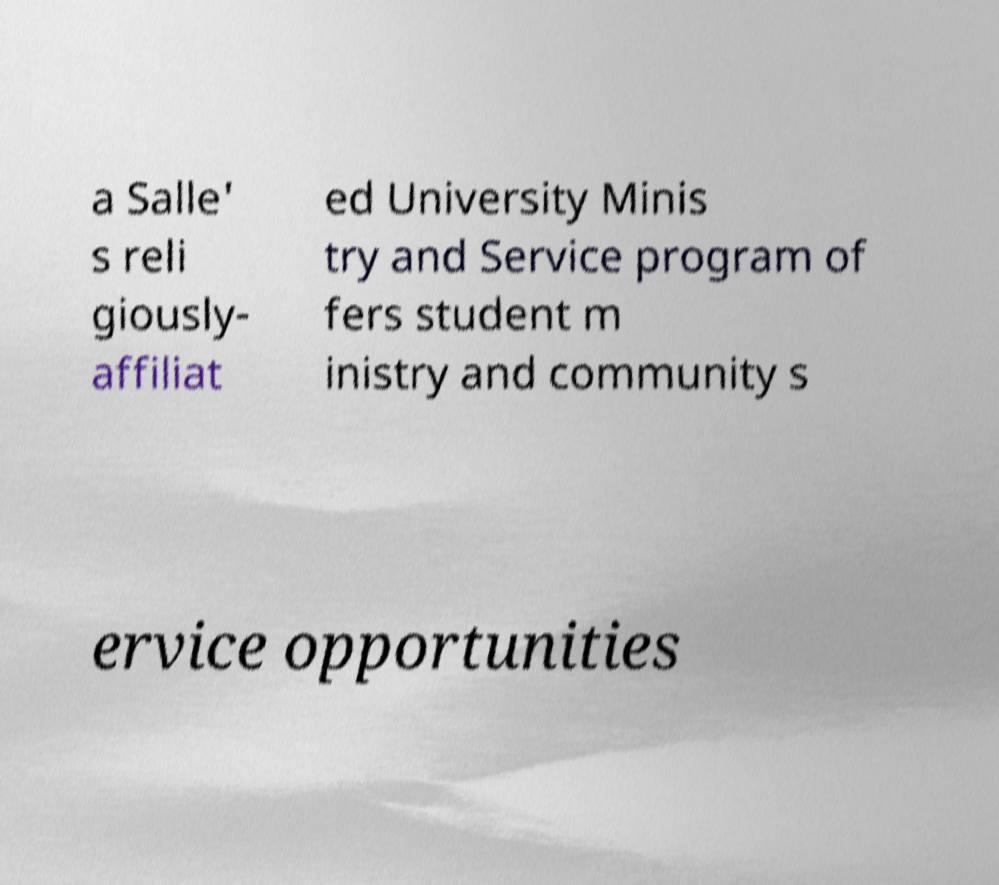Could you extract and type out the text from this image? a Salle' s reli giously- affiliat ed University Minis try and Service program of fers student m inistry and community s ervice opportunities 